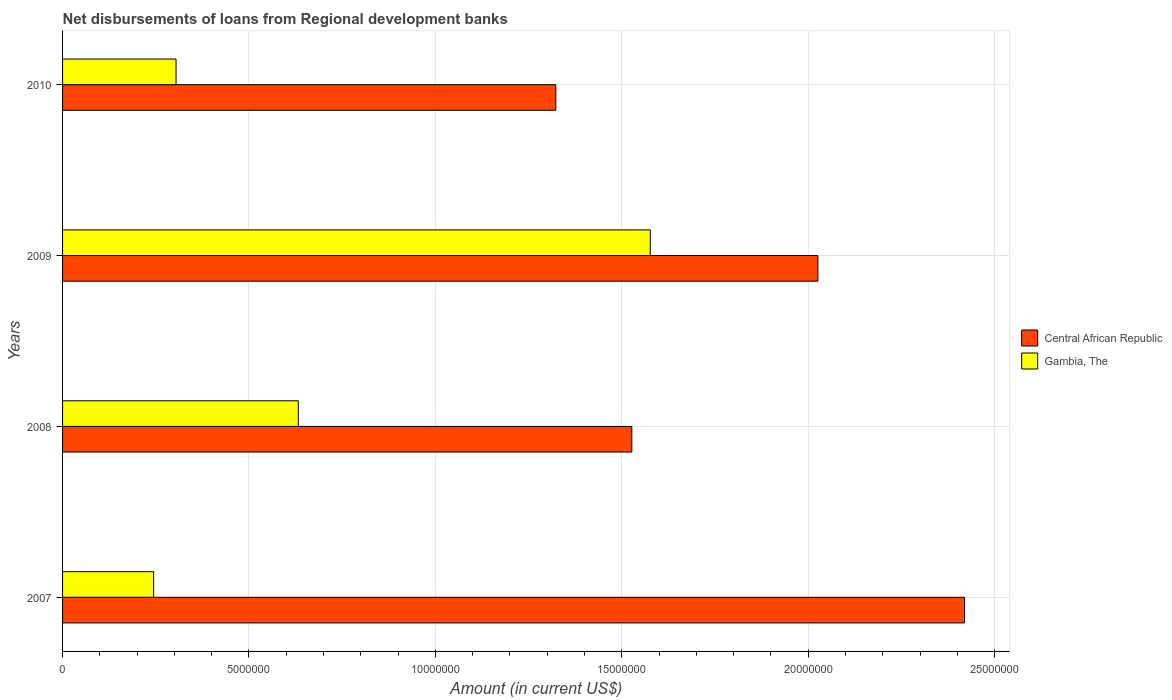How many different coloured bars are there?
Make the answer very short. 2. How many bars are there on the 4th tick from the top?
Offer a very short reply. 2. How many bars are there on the 1st tick from the bottom?
Offer a terse response. 2. In how many cases, is the number of bars for a given year not equal to the number of legend labels?
Provide a succinct answer. 0. What is the amount of disbursements of loans from regional development banks in Gambia, The in 2009?
Offer a very short reply. 1.58e+07. Across all years, what is the maximum amount of disbursements of loans from regional development banks in Central African Republic?
Your answer should be very brief. 2.42e+07. Across all years, what is the minimum amount of disbursements of loans from regional development banks in Gambia, The?
Make the answer very short. 2.44e+06. What is the total amount of disbursements of loans from regional development banks in Central African Republic in the graph?
Provide a short and direct response. 7.30e+07. What is the difference between the amount of disbursements of loans from regional development banks in Gambia, The in 2009 and that in 2010?
Provide a succinct answer. 1.27e+07. What is the difference between the amount of disbursements of loans from regional development banks in Gambia, The in 2008 and the amount of disbursements of loans from regional development banks in Central African Republic in 2007?
Your response must be concise. -1.79e+07. What is the average amount of disbursements of loans from regional development banks in Gambia, The per year?
Your answer should be compact. 6.89e+06. In the year 2008, what is the difference between the amount of disbursements of loans from regional development banks in Gambia, The and amount of disbursements of loans from regional development banks in Central African Republic?
Provide a short and direct response. -8.95e+06. What is the ratio of the amount of disbursements of loans from regional development banks in Gambia, The in 2008 to that in 2010?
Your answer should be compact. 2.08. Is the amount of disbursements of loans from regional development banks in Central African Republic in 2007 less than that in 2008?
Offer a very short reply. No. What is the difference between the highest and the second highest amount of disbursements of loans from regional development banks in Gambia, The?
Offer a terse response. 9.44e+06. What is the difference between the highest and the lowest amount of disbursements of loans from regional development banks in Gambia, The?
Keep it short and to the point. 1.33e+07. What does the 2nd bar from the top in 2007 represents?
Offer a terse response. Central African Republic. What does the 2nd bar from the bottom in 2009 represents?
Keep it short and to the point. Gambia, The. How many years are there in the graph?
Provide a succinct answer. 4. What is the difference between two consecutive major ticks on the X-axis?
Offer a terse response. 5.00e+06. Does the graph contain grids?
Your response must be concise. Yes. What is the title of the graph?
Keep it short and to the point. Net disbursements of loans from Regional development banks. Does "Belgium" appear as one of the legend labels in the graph?
Make the answer very short. No. What is the label or title of the X-axis?
Make the answer very short. Amount (in current US$). What is the Amount (in current US$) of Central African Republic in 2007?
Make the answer very short. 2.42e+07. What is the Amount (in current US$) of Gambia, The in 2007?
Make the answer very short. 2.44e+06. What is the Amount (in current US$) in Central African Republic in 2008?
Make the answer very short. 1.53e+07. What is the Amount (in current US$) in Gambia, The in 2008?
Keep it short and to the point. 6.32e+06. What is the Amount (in current US$) in Central African Republic in 2009?
Ensure brevity in your answer.  2.03e+07. What is the Amount (in current US$) of Gambia, The in 2009?
Provide a succinct answer. 1.58e+07. What is the Amount (in current US$) of Central African Republic in 2010?
Keep it short and to the point. 1.32e+07. What is the Amount (in current US$) in Gambia, The in 2010?
Ensure brevity in your answer.  3.04e+06. Across all years, what is the maximum Amount (in current US$) in Central African Republic?
Your response must be concise. 2.42e+07. Across all years, what is the maximum Amount (in current US$) in Gambia, The?
Provide a succinct answer. 1.58e+07. Across all years, what is the minimum Amount (in current US$) of Central African Republic?
Provide a short and direct response. 1.32e+07. Across all years, what is the minimum Amount (in current US$) in Gambia, The?
Make the answer very short. 2.44e+06. What is the total Amount (in current US$) of Central African Republic in the graph?
Keep it short and to the point. 7.30e+07. What is the total Amount (in current US$) in Gambia, The in the graph?
Provide a short and direct response. 2.76e+07. What is the difference between the Amount (in current US$) in Central African Republic in 2007 and that in 2008?
Give a very brief answer. 8.92e+06. What is the difference between the Amount (in current US$) of Gambia, The in 2007 and that in 2008?
Offer a terse response. -3.88e+06. What is the difference between the Amount (in current US$) in Central African Republic in 2007 and that in 2009?
Keep it short and to the point. 3.93e+06. What is the difference between the Amount (in current US$) in Gambia, The in 2007 and that in 2009?
Keep it short and to the point. -1.33e+07. What is the difference between the Amount (in current US$) of Central African Republic in 2007 and that in 2010?
Ensure brevity in your answer.  1.10e+07. What is the difference between the Amount (in current US$) of Gambia, The in 2007 and that in 2010?
Offer a very short reply. -6.02e+05. What is the difference between the Amount (in current US$) of Central African Republic in 2008 and that in 2009?
Provide a succinct answer. -4.99e+06. What is the difference between the Amount (in current US$) of Gambia, The in 2008 and that in 2009?
Ensure brevity in your answer.  -9.44e+06. What is the difference between the Amount (in current US$) of Central African Republic in 2008 and that in 2010?
Provide a short and direct response. 2.04e+06. What is the difference between the Amount (in current US$) of Gambia, The in 2008 and that in 2010?
Give a very brief answer. 3.28e+06. What is the difference between the Amount (in current US$) of Central African Republic in 2009 and that in 2010?
Provide a short and direct response. 7.03e+06. What is the difference between the Amount (in current US$) of Gambia, The in 2009 and that in 2010?
Make the answer very short. 1.27e+07. What is the difference between the Amount (in current US$) of Central African Republic in 2007 and the Amount (in current US$) of Gambia, The in 2008?
Your answer should be very brief. 1.79e+07. What is the difference between the Amount (in current US$) of Central African Republic in 2007 and the Amount (in current US$) of Gambia, The in 2009?
Ensure brevity in your answer.  8.43e+06. What is the difference between the Amount (in current US$) of Central African Republic in 2007 and the Amount (in current US$) of Gambia, The in 2010?
Provide a succinct answer. 2.12e+07. What is the difference between the Amount (in current US$) in Central African Republic in 2008 and the Amount (in current US$) in Gambia, The in 2009?
Provide a short and direct response. -4.95e+05. What is the difference between the Amount (in current US$) in Central African Republic in 2008 and the Amount (in current US$) in Gambia, The in 2010?
Ensure brevity in your answer.  1.22e+07. What is the difference between the Amount (in current US$) in Central African Republic in 2009 and the Amount (in current US$) in Gambia, The in 2010?
Keep it short and to the point. 1.72e+07. What is the average Amount (in current US$) of Central African Republic per year?
Make the answer very short. 1.82e+07. What is the average Amount (in current US$) of Gambia, The per year?
Offer a terse response. 6.89e+06. In the year 2007, what is the difference between the Amount (in current US$) in Central African Republic and Amount (in current US$) in Gambia, The?
Provide a succinct answer. 2.18e+07. In the year 2008, what is the difference between the Amount (in current US$) of Central African Republic and Amount (in current US$) of Gambia, The?
Offer a terse response. 8.95e+06. In the year 2009, what is the difference between the Amount (in current US$) of Central African Republic and Amount (in current US$) of Gambia, The?
Your answer should be compact. 4.50e+06. In the year 2010, what is the difference between the Amount (in current US$) of Central African Republic and Amount (in current US$) of Gambia, The?
Ensure brevity in your answer.  1.02e+07. What is the ratio of the Amount (in current US$) of Central African Republic in 2007 to that in 2008?
Your answer should be very brief. 1.58. What is the ratio of the Amount (in current US$) of Gambia, The in 2007 to that in 2008?
Offer a very short reply. 0.39. What is the ratio of the Amount (in current US$) of Central African Republic in 2007 to that in 2009?
Give a very brief answer. 1.19. What is the ratio of the Amount (in current US$) in Gambia, The in 2007 to that in 2009?
Your answer should be very brief. 0.15. What is the ratio of the Amount (in current US$) in Central African Republic in 2007 to that in 2010?
Your response must be concise. 1.83. What is the ratio of the Amount (in current US$) in Gambia, The in 2007 to that in 2010?
Your answer should be very brief. 0.8. What is the ratio of the Amount (in current US$) in Central African Republic in 2008 to that in 2009?
Your answer should be compact. 0.75. What is the ratio of the Amount (in current US$) of Gambia, The in 2008 to that in 2009?
Your answer should be compact. 0.4. What is the ratio of the Amount (in current US$) of Central African Republic in 2008 to that in 2010?
Your answer should be compact. 1.15. What is the ratio of the Amount (in current US$) of Gambia, The in 2008 to that in 2010?
Your answer should be very brief. 2.08. What is the ratio of the Amount (in current US$) in Central African Republic in 2009 to that in 2010?
Your answer should be compact. 1.53. What is the ratio of the Amount (in current US$) in Gambia, The in 2009 to that in 2010?
Your response must be concise. 5.18. What is the difference between the highest and the second highest Amount (in current US$) in Central African Republic?
Offer a very short reply. 3.93e+06. What is the difference between the highest and the second highest Amount (in current US$) of Gambia, The?
Your answer should be very brief. 9.44e+06. What is the difference between the highest and the lowest Amount (in current US$) of Central African Republic?
Your response must be concise. 1.10e+07. What is the difference between the highest and the lowest Amount (in current US$) in Gambia, The?
Offer a terse response. 1.33e+07. 